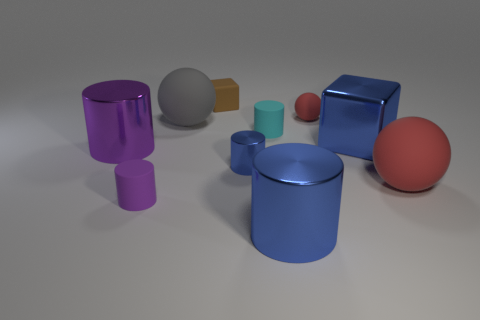How many objects are either small matte cylinders or purple matte cylinders?
Provide a succinct answer. 2. There is a large metallic cylinder to the left of the small cyan rubber cylinder; is there a shiny thing that is on the left side of it?
Provide a succinct answer. No. Are there more big balls left of the cyan cylinder than large cubes in front of the purple rubber cylinder?
Give a very brief answer. Yes. There is a big cylinder that is the same color as the small metal object; what is its material?
Your answer should be very brief. Metal. How many big metal cylinders have the same color as the small metal thing?
Provide a succinct answer. 1. Do the cylinder that is in front of the tiny purple object and the block that is on the right side of the tiny blue object have the same color?
Your answer should be very brief. Yes. Are there any tiny red rubber objects behind the cyan cylinder?
Provide a succinct answer. Yes. What material is the small cyan object?
Provide a succinct answer. Rubber. What shape is the large blue thing that is left of the blue cube?
Keep it short and to the point. Cylinder. What size is the other rubber ball that is the same color as the tiny matte sphere?
Offer a very short reply. Large. 